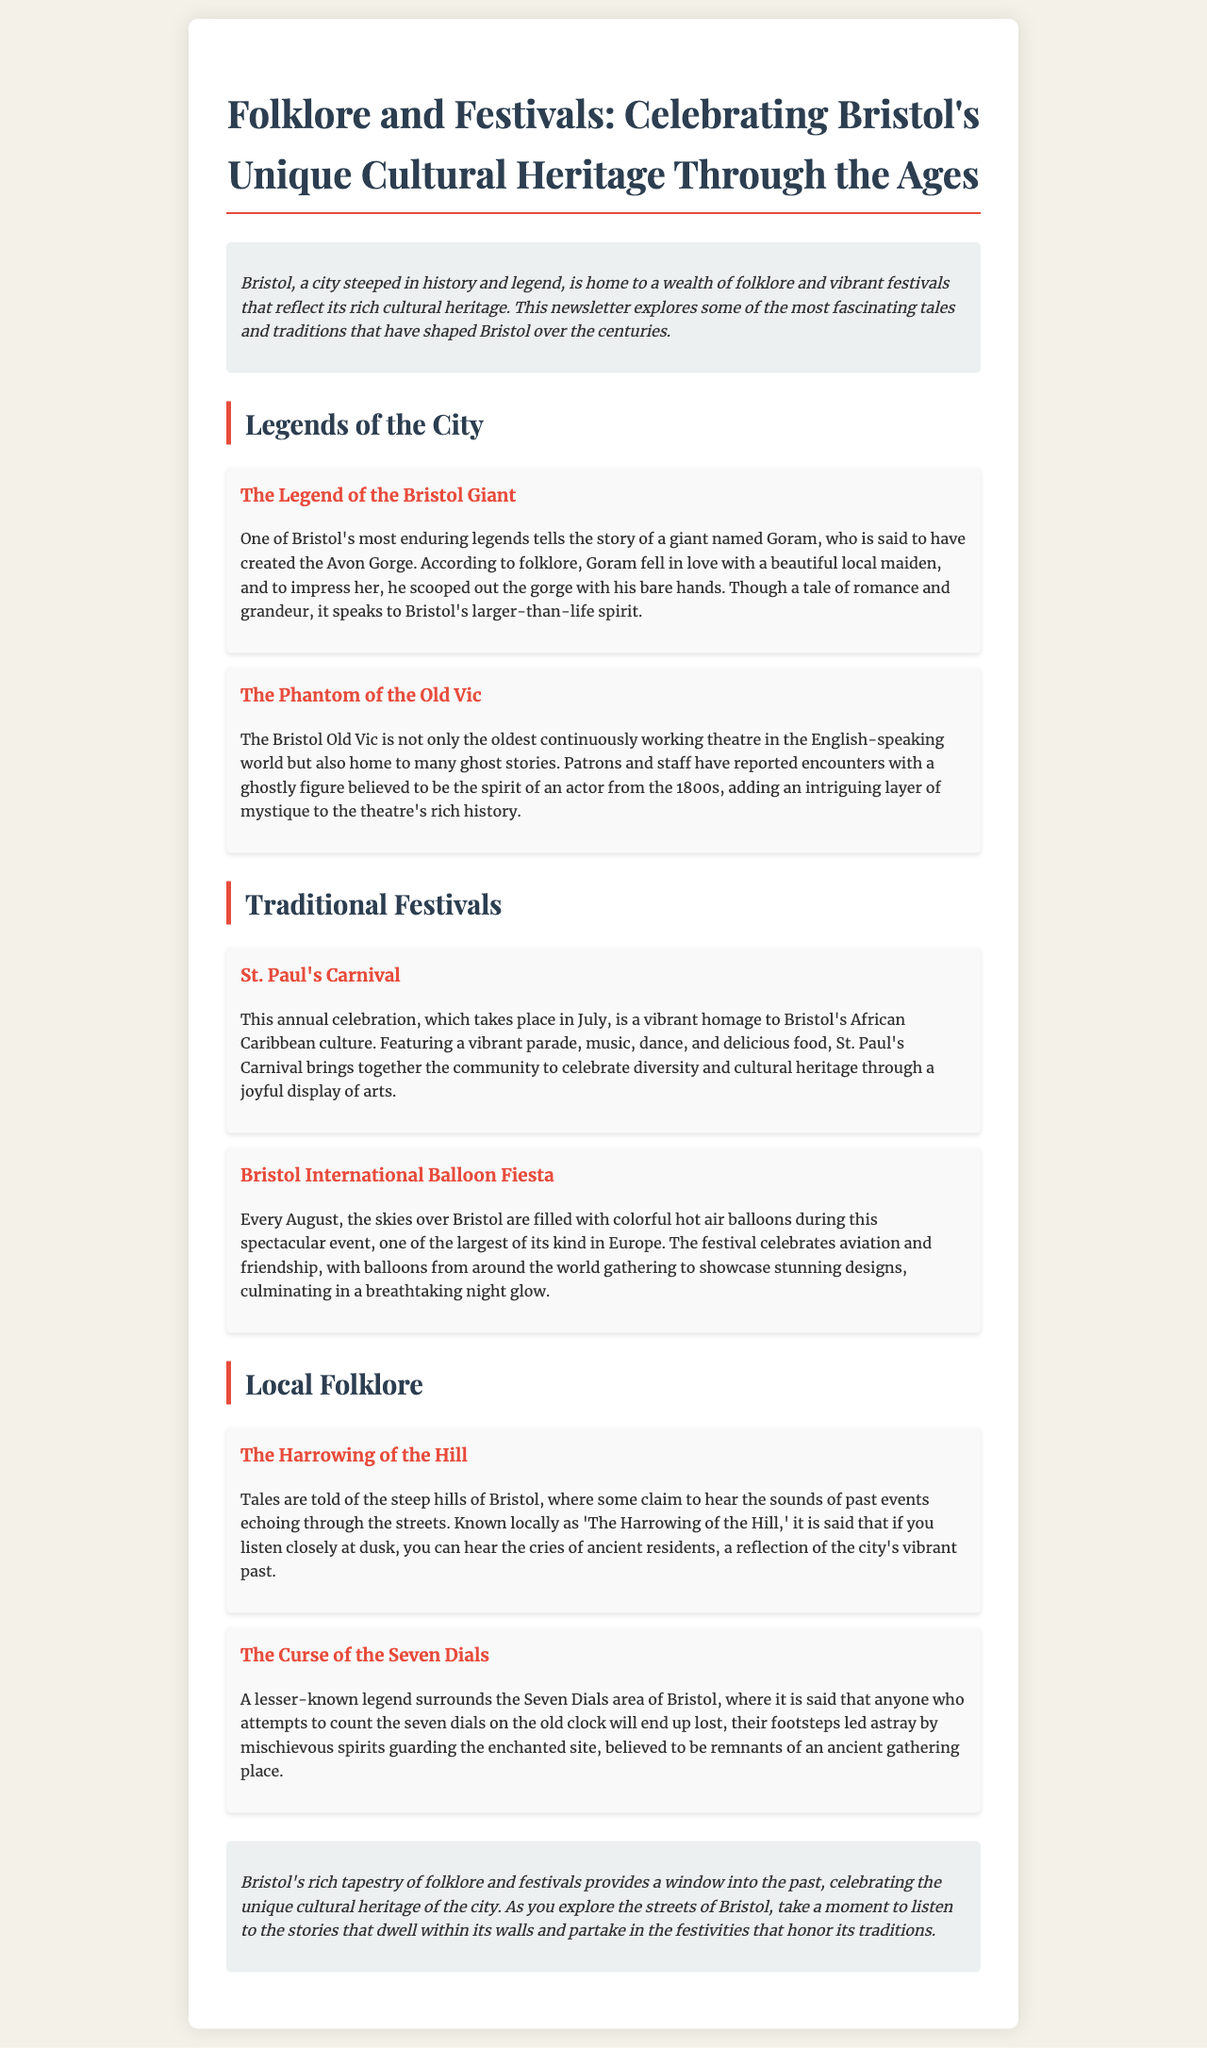What is the title of the newsletter? The title of the newsletter is provided prominently at the top of the document, introducing the main theme of the content.
Answer: Folklore and Festivals: Celebrating Bristol's Unique Cultural Heritage Through the Ages Who is the giant in Bristol's legend? The document specifically mentions the name of the giant involved in the enduring legend of Bristol.
Answer: Goram What is the oldest continuously working theatre mentioned? The document details the famous theatre that holds this title, highlighting its significance in Bristol's history.
Answer: Bristol Old Vic What month does St. Paul's Carnival take place? The specific time of year for the festival is stated directly in the content, indicating its annual occurrence.
Answer: July What happens during the Bristol International Balloon Fiesta? The document explains the main event and activities that take place during this large festival in Bristol.
Answer: Colorful hot air balloons fill the skies What is the local term used for the sounds of past events in Bristol? The newsletter highlights a specific term associated with the local folklore describing echoes of history in the city.
Answer: The Harrowing of the Hill What are the seven dials associated with? The content describes an element of the folklore linked to a location in Bristol, specifically referencing a mythical aspect.
Answer: An old clock How does the newsletter describe the role of folklore and festivals in Bristol? The conclusion of the newsletter emphasizes the significance of these traditions in relation to the city's cultural heritage.
Answer: A window into the past 